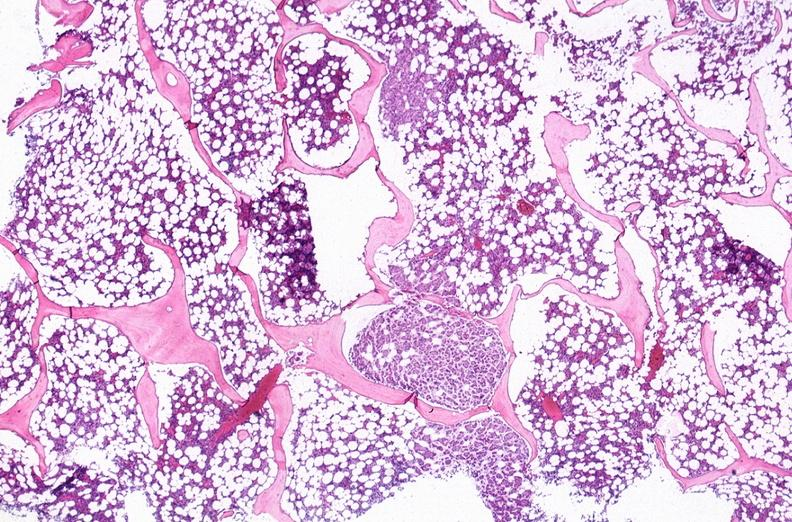what is present?
Answer the question using a single word or phrase. Hematologic 